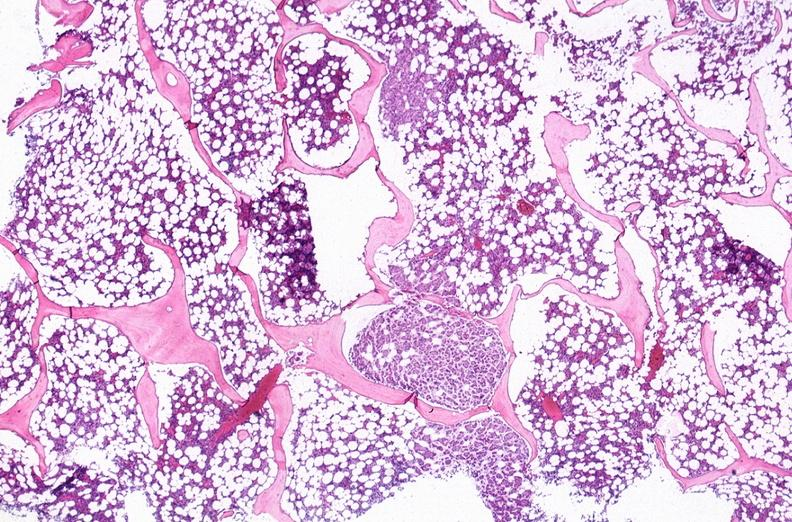what is present?
Answer the question using a single word or phrase. Hematologic 